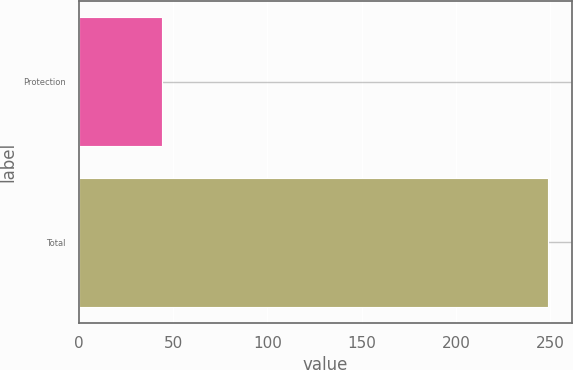Convert chart to OTSL. <chart><loc_0><loc_0><loc_500><loc_500><bar_chart><fcel>Protection<fcel>Total<nl><fcel>44<fcel>249<nl></chart> 